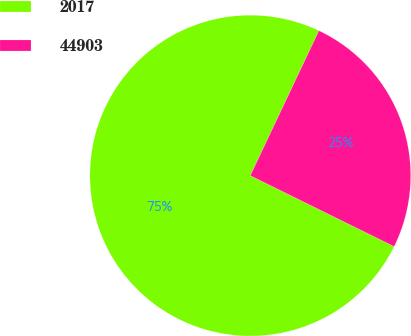Convert chart to OTSL. <chart><loc_0><loc_0><loc_500><loc_500><pie_chart><fcel>2017<fcel>44903<nl><fcel>74.75%<fcel>25.25%<nl></chart> 